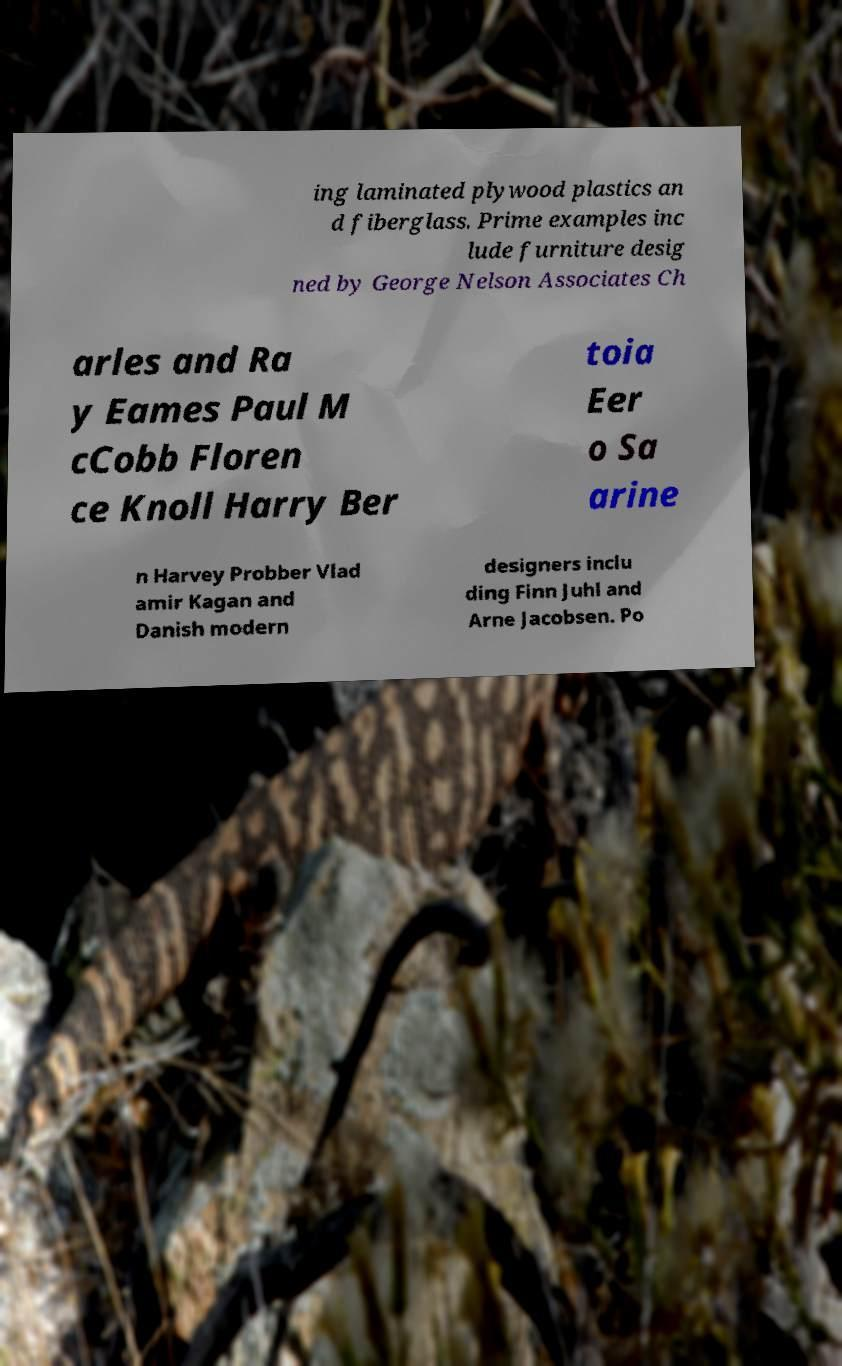Could you assist in decoding the text presented in this image and type it out clearly? ing laminated plywood plastics an d fiberglass. Prime examples inc lude furniture desig ned by George Nelson Associates Ch arles and Ra y Eames Paul M cCobb Floren ce Knoll Harry Ber toia Eer o Sa arine n Harvey Probber Vlad amir Kagan and Danish modern designers inclu ding Finn Juhl and Arne Jacobsen. Po 